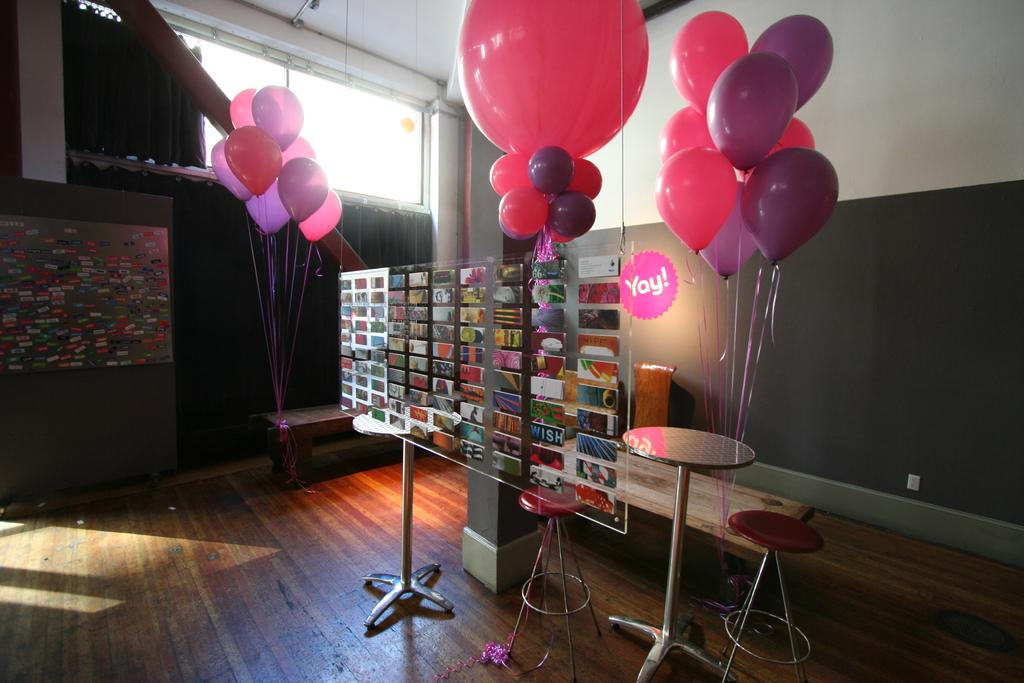<image>
Summarize the visual content of the image. A room with a table and balloon bouquets around the room and a pink sign that says Yay! 